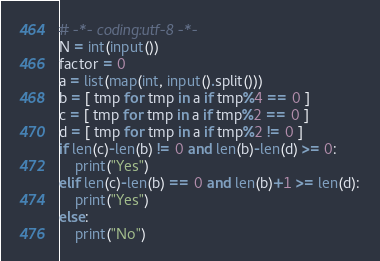Convert code to text. <code><loc_0><loc_0><loc_500><loc_500><_Python_># -*- coding:utf-8 -*-
N = int(input())
factor = 0
a = list(map(int, input().split()))
b = [ tmp for tmp in a if tmp%4 == 0 ]
c = [ tmp for tmp in a if tmp%2 == 0 ]
d = [ tmp for tmp in a if tmp%2 != 0 ]
if len(c)-len(b) != 0 and len(b)-len(d) >= 0:
    print("Yes")
elif len(c)-len(b) == 0 and len(b)+1 >= len(d):
    print("Yes")
else:
    print("No")</code> 